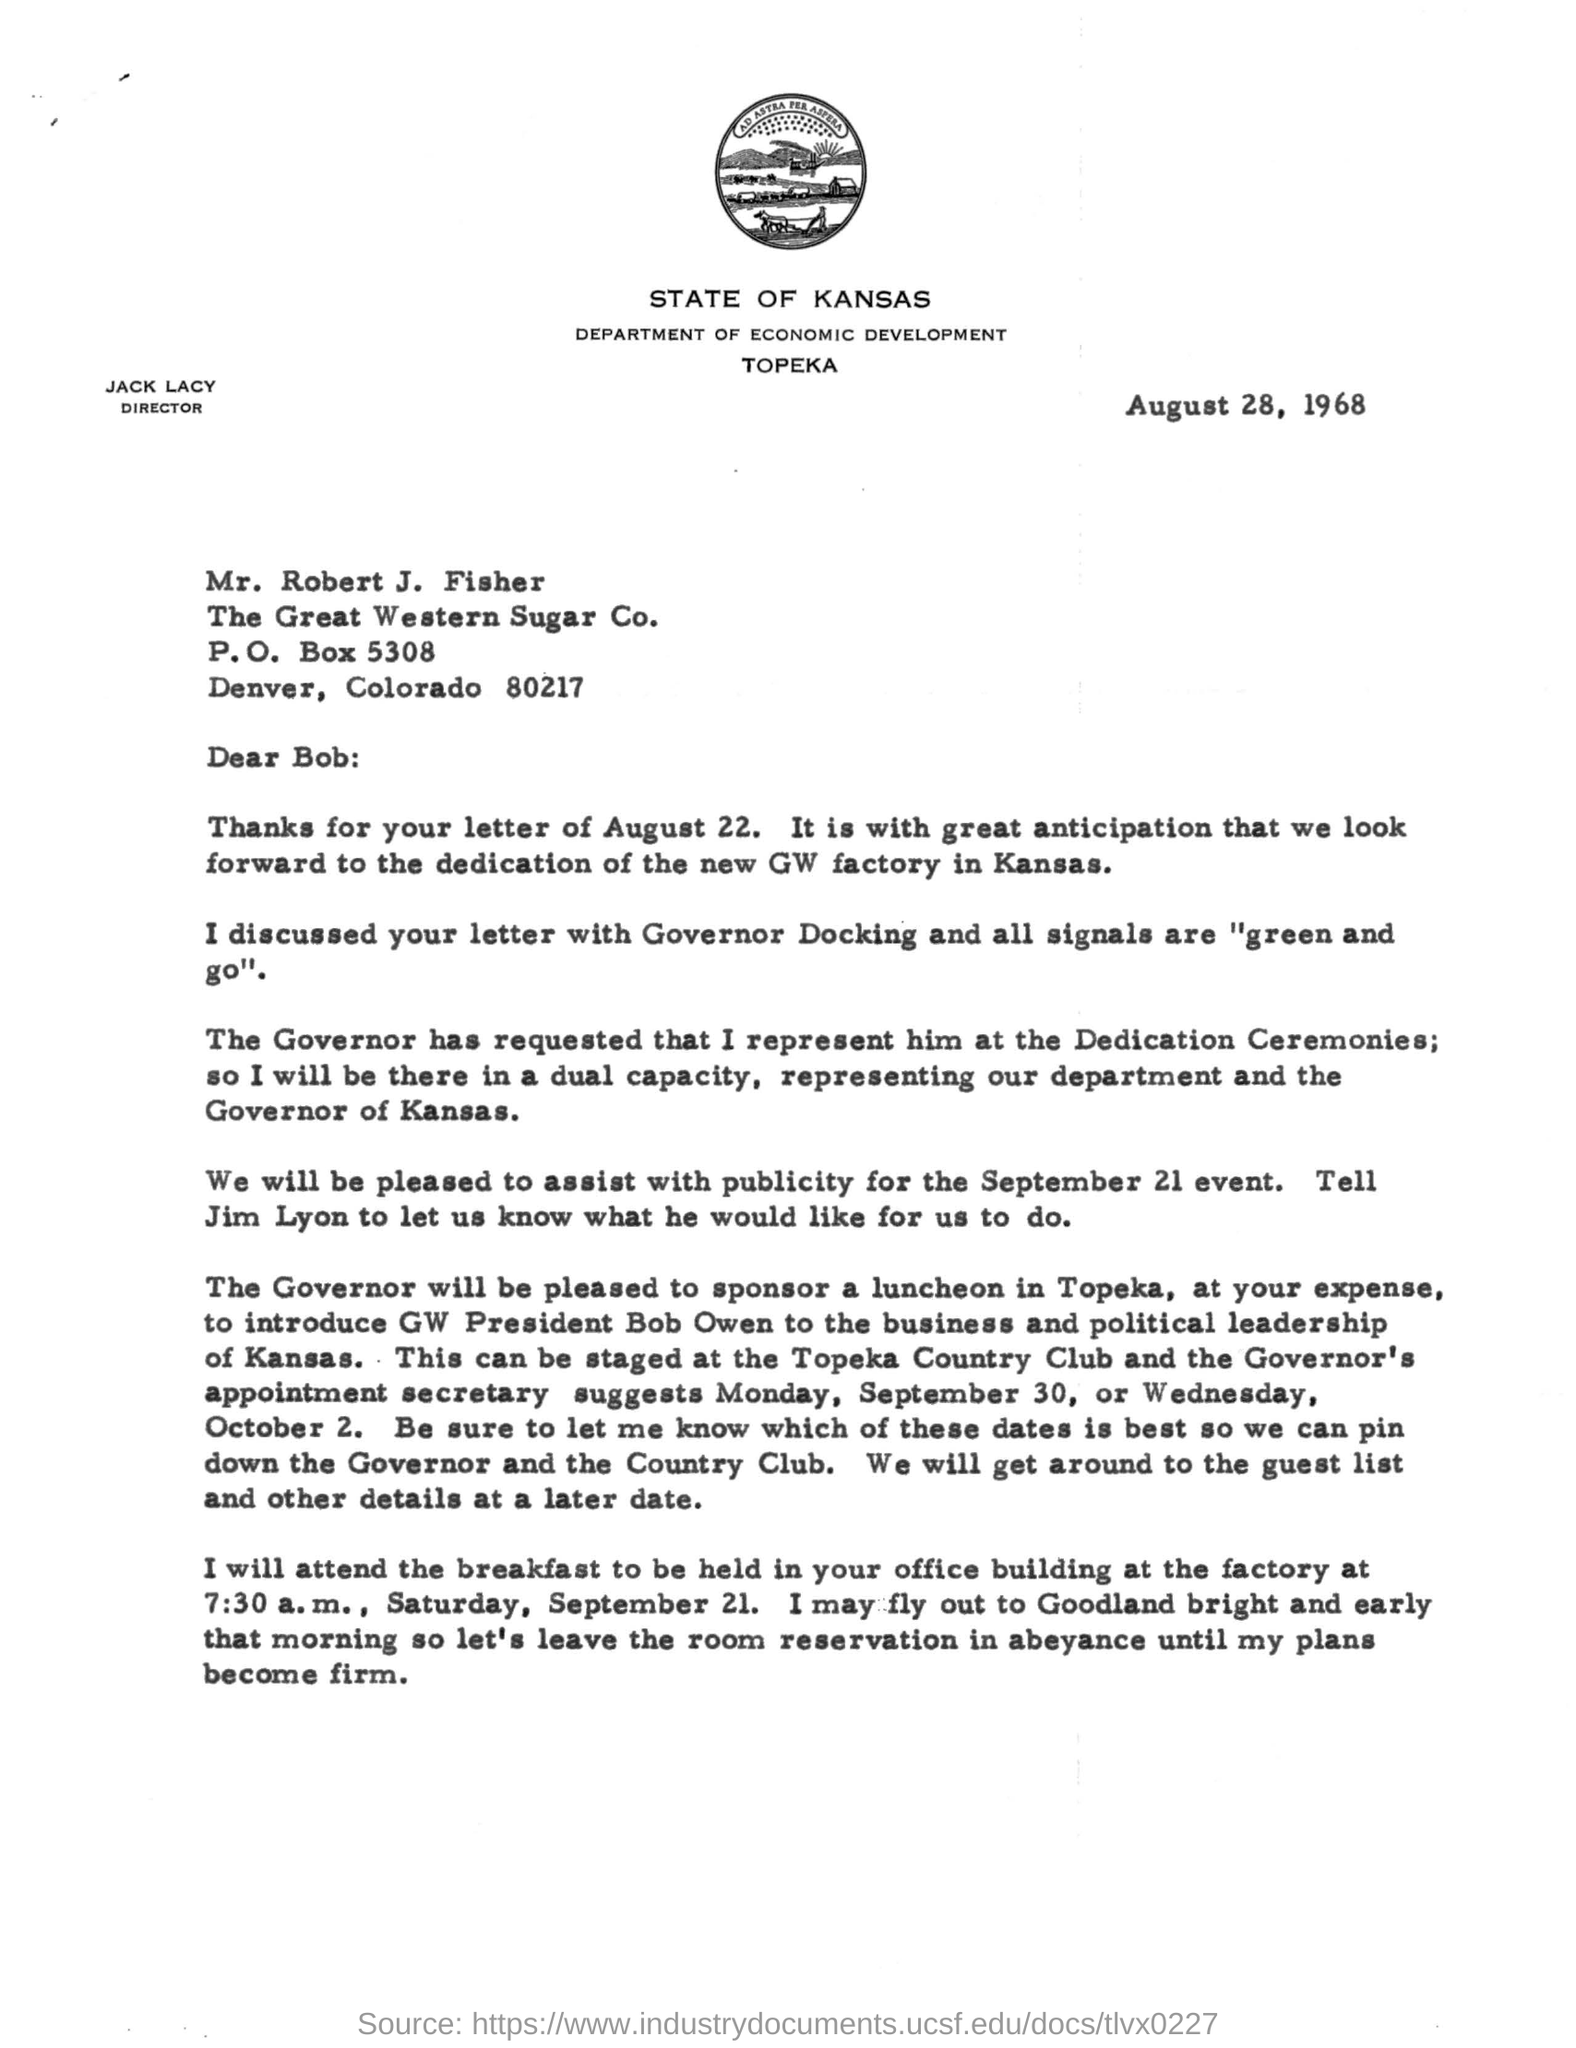What is the Heading of the document ?
Offer a very short reply. State of kansas. What is the P.O.Box number ?
Keep it short and to the point. 5308. What is the company name ?
Keep it short and to the point. The Great Western Sugar Co. What is the director name ?
Your answer should be very brief. Jack lacy. 